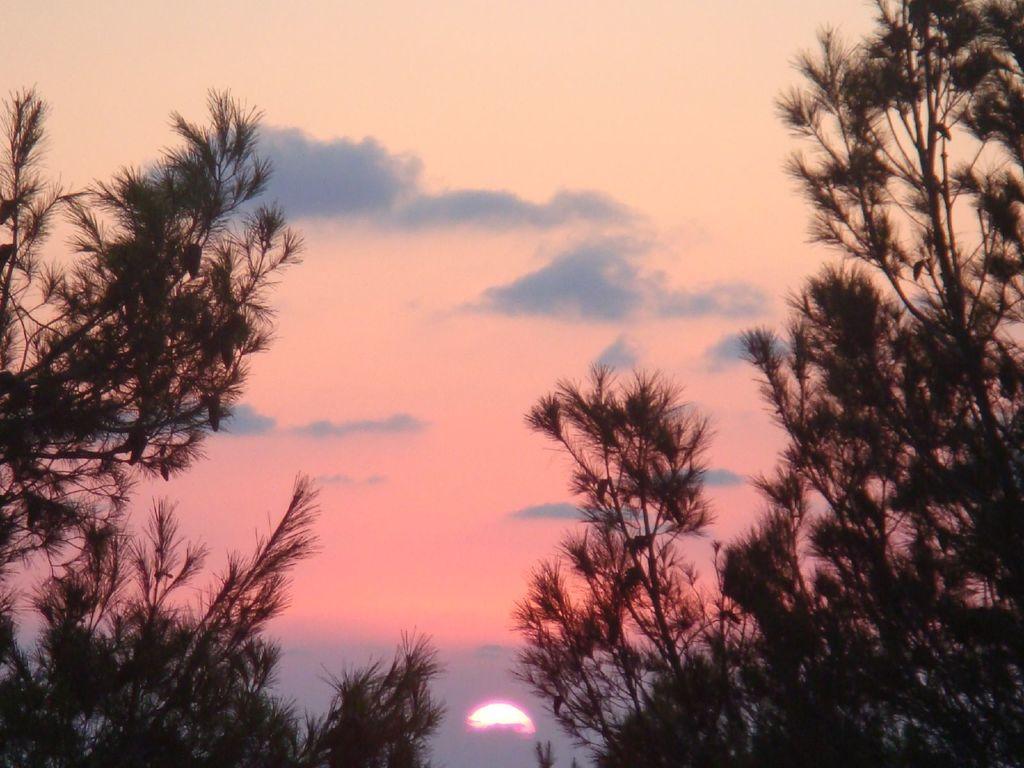Can you describe this image briefly? Here we can see trees. In the background we can see the sun and clouds in the sky. 